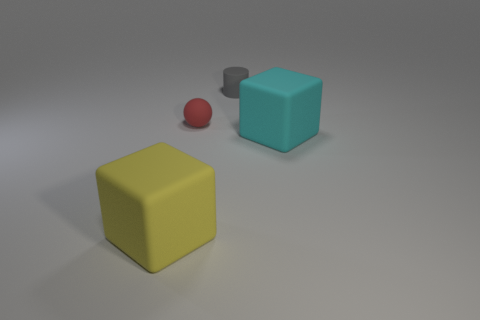Add 1 purple blocks. How many objects exist? 5 Subtract 2 cubes. How many cubes are left? 0 Subtract all balls. How many objects are left? 3 Subtract all yellow blocks. How many blocks are left? 1 Subtract all purple blocks. Subtract all gray cylinders. How many blocks are left? 2 Subtract all brown spheres. Subtract all tiny gray matte cylinders. How many objects are left? 3 Add 4 big yellow matte cubes. How many big yellow matte cubes are left? 5 Add 3 tiny yellow cylinders. How many tiny yellow cylinders exist? 3 Subtract 1 red balls. How many objects are left? 3 